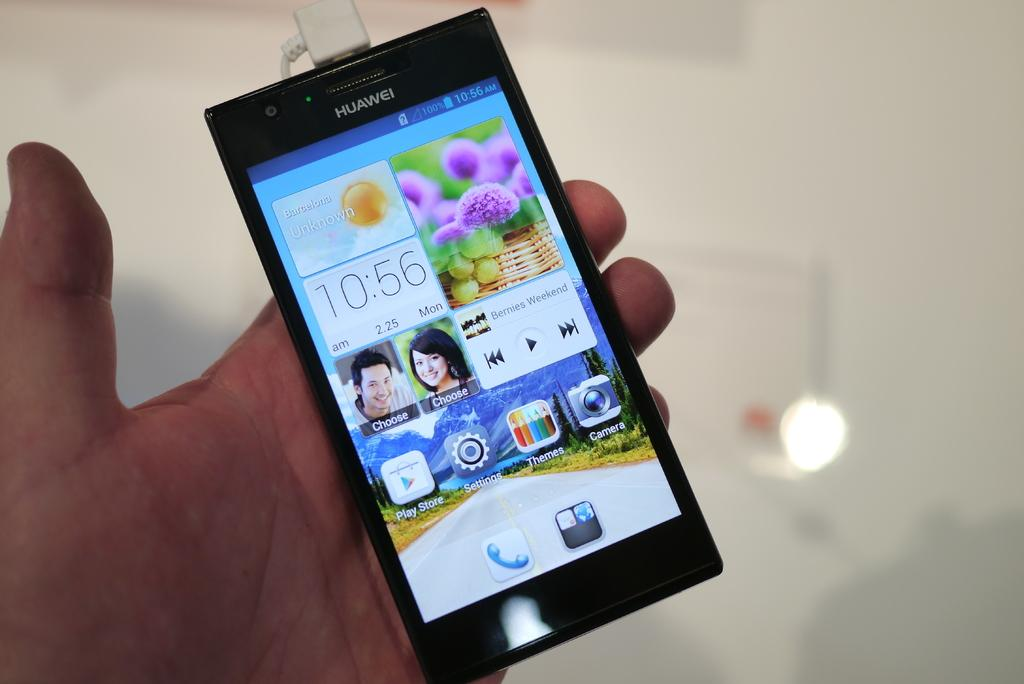Provide a one-sentence caption for the provided image. A Huawei phone displays a clock and icons for Themes, Camera and Play Store on its screen. 